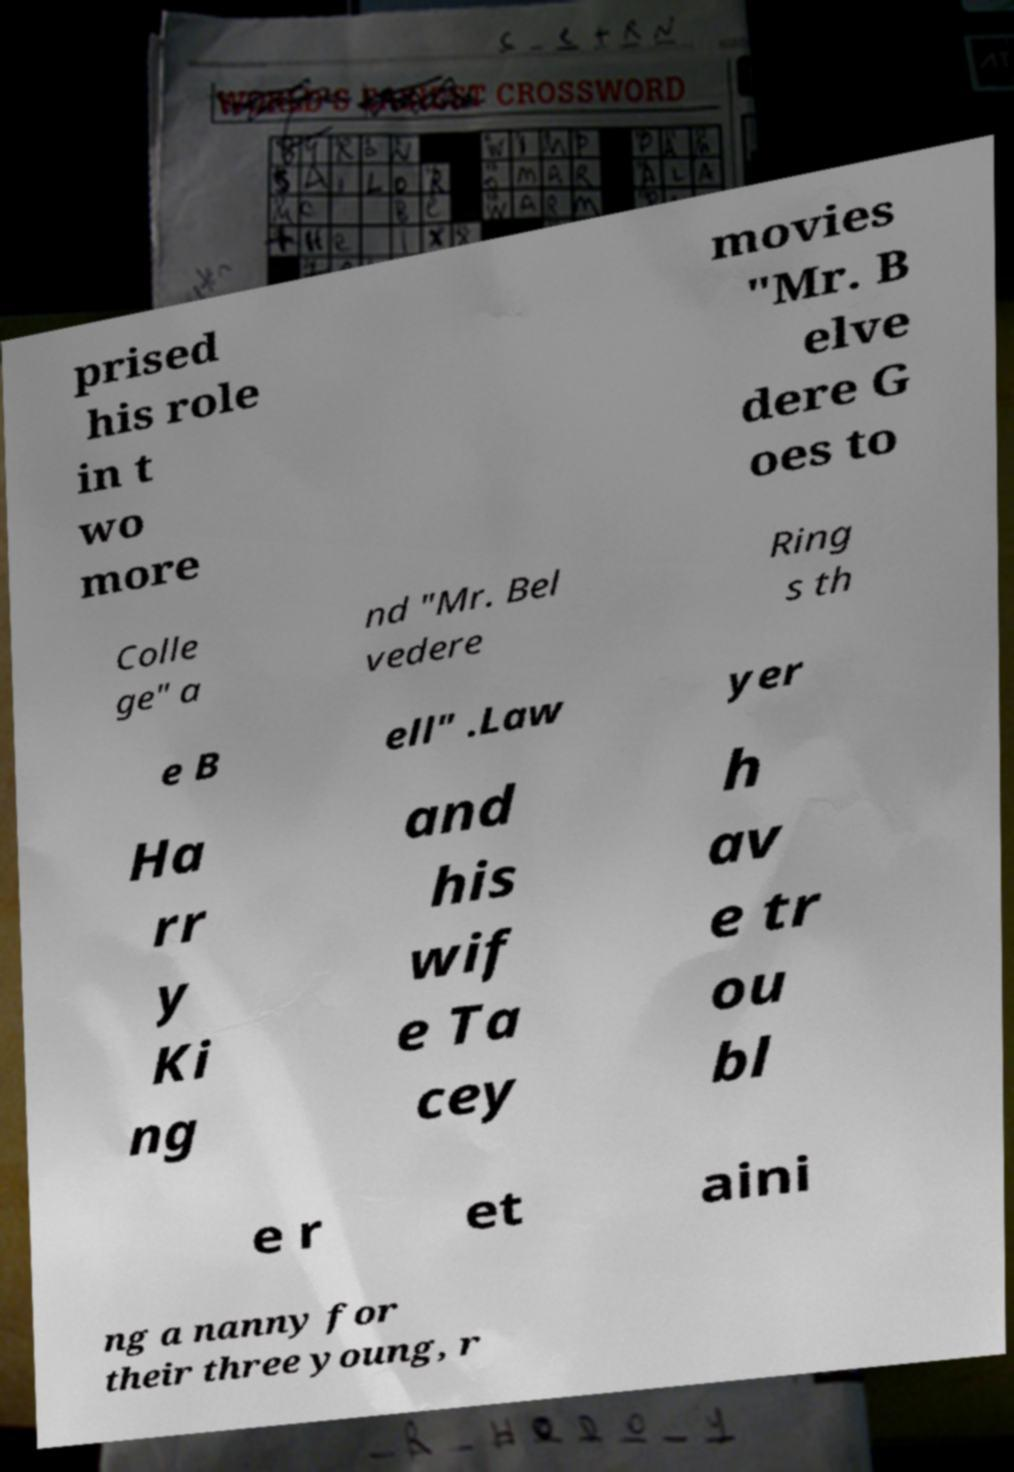I need the written content from this picture converted into text. Can you do that? prised his role in t wo more movies "Mr. B elve dere G oes to Colle ge" a nd "Mr. Bel vedere Ring s th e B ell" .Law yer Ha rr y Ki ng and his wif e Ta cey h av e tr ou bl e r et aini ng a nanny for their three young, r 